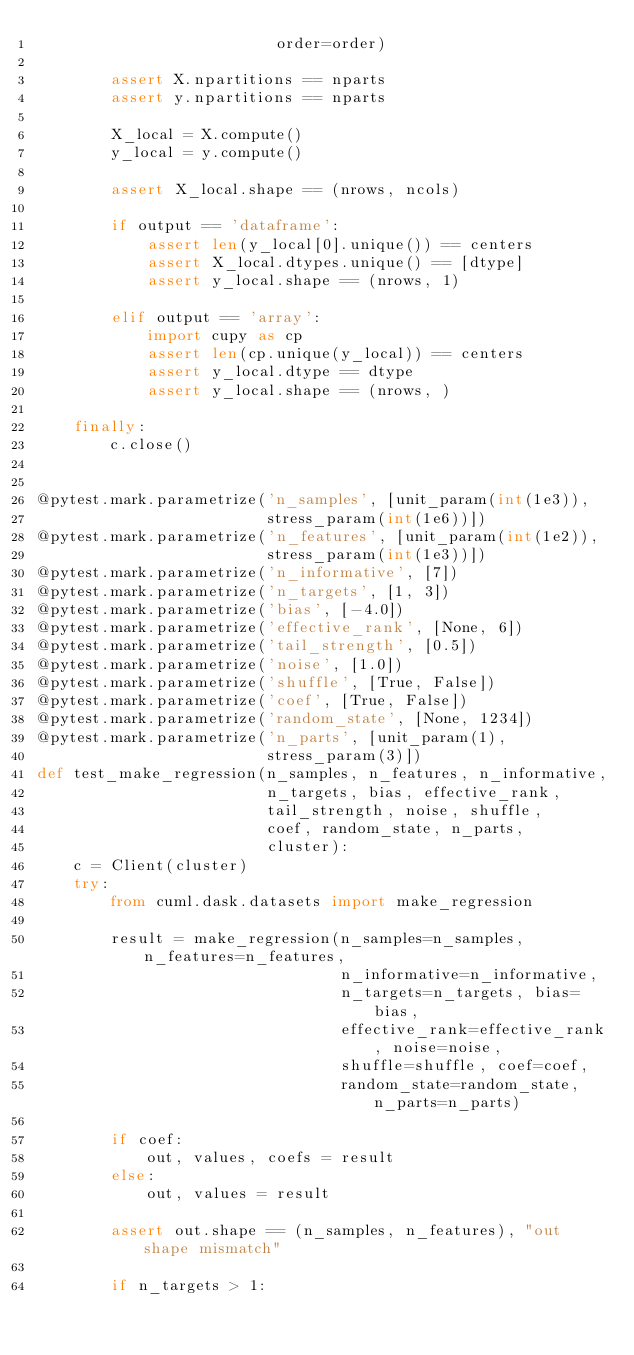<code> <loc_0><loc_0><loc_500><loc_500><_Python_>                          order=order)

        assert X.npartitions == nparts
        assert y.npartitions == nparts

        X_local = X.compute()
        y_local = y.compute()

        assert X_local.shape == (nrows, ncols)

        if output == 'dataframe':
            assert len(y_local[0].unique()) == centers
            assert X_local.dtypes.unique() == [dtype]
            assert y_local.shape == (nrows, 1)

        elif output == 'array':
            import cupy as cp
            assert len(cp.unique(y_local)) == centers
            assert y_local.dtype == dtype
            assert y_local.shape == (nrows, )

    finally:
        c.close()


@pytest.mark.parametrize('n_samples', [unit_param(int(1e3)),
                         stress_param(int(1e6))])
@pytest.mark.parametrize('n_features', [unit_param(int(1e2)),
                         stress_param(int(1e3))])
@pytest.mark.parametrize('n_informative', [7])
@pytest.mark.parametrize('n_targets', [1, 3])
@pytest.mark.parametrize('bias', [-4.0])
@pytest.mark.parametrize('effective_rank', [None, 6])
@pytest.mark.parametrize('tail_strength', [0.5])
@pytest.mark.parametrize('noise', [1.0])
@pytest.mark.parametrize('shuffle', [True, False])
@pytest.mark.parametrize('coef', [True, False])
@pytest.mark.parametrize('random_state', [None, 1234])
@pytest.mark.parametrize('n_parts', [unit_param(1),
                         stress_param(3)])
def test_make_regression(n_samples, n_features, n_informative,
                         n_targets, bias, effective_rank,
                         tail_strength, noise, shuffle,
                         coef, random_state, n_parts,
                         cluster):
    c = Client(cluster)
    try:
        from cuml.dask.datasets import make_regression

        result = make_regression(n_samples=n_samples, n_features=n_features,
                                 n_informative=n_informative,
                                 n_targets=n_targets, bias=bias,
                                 effective_rank=effective_rank, noise=noise,
                                 shuffle=shuffle, coef=coef,
                                 random_state=random_state, n_parts=n_parts)

        if coef:
            out, values, coefs = result
        else:
            out, values = result

        assert out.shape == (n_samples, n_features), "out shape mismatch"

        if n_targets > 1:</code> 